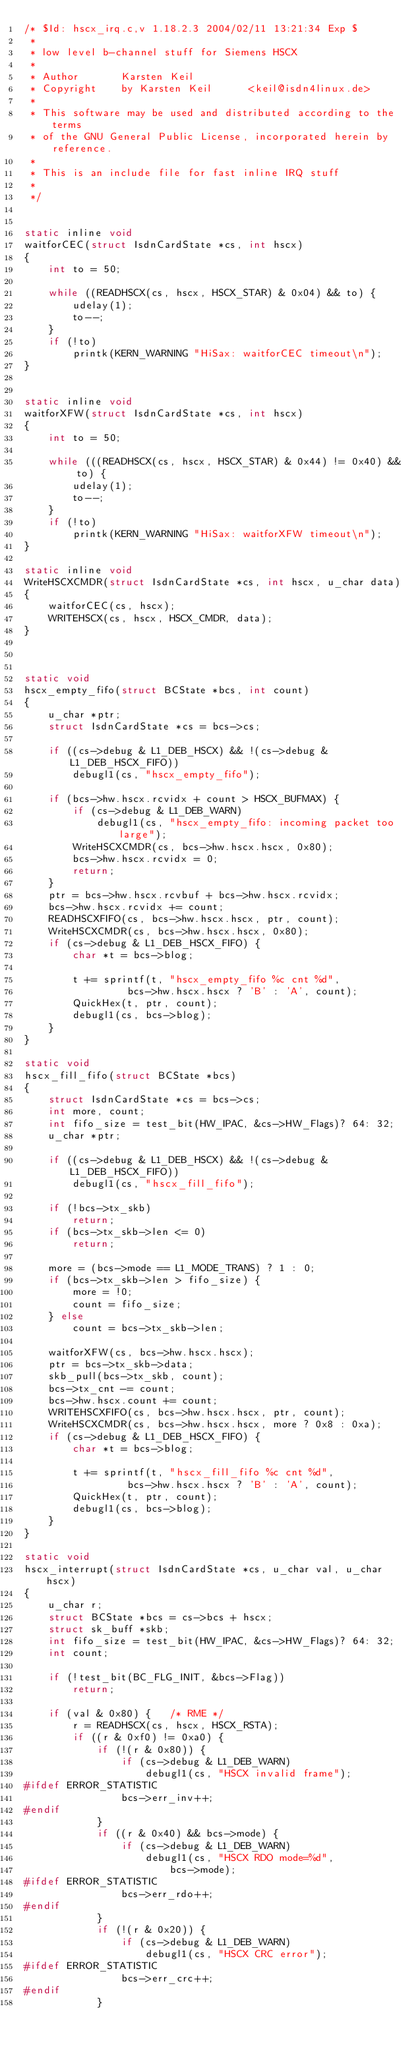Convert code to text. <code><loc_0><loc_0><loc_500><loc_500><_C_>/* $Id: hscx_irq.c,v 1.18.2.3 2004/02/11 13:21:34 Exp $
 *
 * low level b-channel stuff for Siemens HSCX
 *
 * Author       Karsten Keil
 * Copyright    by Karsten Keil      <keil@isdn4linux.de>
 * 
 * This software may be used and distributed according to the terms
 * of the GNU General Public License, incorporated herein by reference.
 *
 * This is an include file for fast inline IRQ stuff
 *
 */


static inline void
waitforCEC(struct IsdnCardState *cs, int hscx)
{
	int to = 50;

	while ((READHSCX(cs, hscx, HSCX_STAR) & 0x04) && to) {
		udelay(1);
		to--;
	}
	if (!to)
		printk(KERN_WARNING "HiSax: waitforCEC timeout\n");
}


static inline void
waitforXFW(struct IsdnCardState *cs, int hscx)
{
	int to = 50;

	while (((READHSCX(cs, hscx, HSCX_STAR) & 0x44) != 0x40) && to) {
		udelay(1);
		to--;
	}
	if (!to)
		printk(KERN_WARNING "HiSax: waitforXFW timeout\n");
}

static inline void
WriteHSCXCMDR(struct IsdnCardState *cs, int hscx, u_char data)
{
	waitforCEC(cs, hscx);
	WRITEHSCX(cs, hscx, HSCX_CMDR, data);
}



static void
hscx_empty_fifo(struct BCState *bcs, int count)
{
	u_char *ptr;
	struct IsdnCardState *cs = bcs->cs;

	if ((cs->debug & L1_DEB_HSCX) && !(cs->debug & L1_DEB_HSCX_FIFO))
		debugl1(cs, "hscx_empty_fifo");

	if (bcs->hw.hscx.rcvidx + count > HSCX_BUFMAX) {
		if (cs->debug & L1_DEB_WARN)
			debugl1(cs, "hscx_empty_fifo: incoming packet too large");
		WriteHSCXCMDR(cs, bcs->hw.hscx.hscx, 0x80);
		bcs->hw.hscx.rcvidx = 0;
		return;
	}
	ptr = bcs->hw.hscx.rcvbuf + bcs->hw.hscx.rcvidx;
	bcs->hw.hscx.rcvidx += count;
	READHSCXFIFO(cs, bcs->hw.hscx.hscx, ptr, count);
	WriteHSCXCMDR(cs, bcs->hw.hscx.hscx, 0x80);
	if (cs->debug & L1_DEB_HSCX_FIFO) {
		char *t = bcs->blog;

		t += sprintf(t, "hscx_empty_fifo %c cnt %d",
			     bcs->hw.hscx.hscx ? 'B' : 'A', count);
		QuickHex(t, ptr, count);
		debugl1(cs, bcs->blog);
	}
}

static void
hscx_fill_fifo(struct BCState *bcs)
{
	struct IsdnCardState *cs = bcs->cs;
	int more, count;
	int fifo_size = test_bit(HW_IPAC, &cs->HW_Flags)? 64: 32;
	u_char *ptr;

	if ((cs->debug & L1_DEB_HSCX) && !(cs->debug & L1_DEB_HSCX_FIFO))
		debugl1(cs, "hscx_fill_fifo");

	if (!bcs->tx_skb)
		return;
	if (bcs->tx_skb->len <= 0)
		return;

	more = (bcs->mode == L1_MODE_TRANS) ? 1 : 0;
	if (bcs->tx_skb->len > fifo_size) {
		more = !0;
		count = fifo_size;
	} else
		count = bcs->tx_skb->len;

	waitforXFW(cs, bcs->hw.hscx.hscx);
	ptr = bcs->tx_skb->data;
	skb_pull(bcs->tx_skb, count);
	bcs->tx_cnt -= count;
	bcs->hw.hscx.count += count;
	WRITEHSCXFIFO(cs, bcs->hw.hscx.hscx, ptr, count);
	WriteHSCXCMDR(cs, bcs->hw.hscx.hscx, more ? 0x8 : 0xa);
	if (cs->debug & L1_DEB_HSCX_FIFO) {
		char *t = bcs->blog;

		t += sprintf(t, "hscx_fill_fifo %c cnt %d",
			     bcs->hw.hscx.hscx ? 'B' : 'A', count);
		QuickHex(t, ptr, count);
		debugl1(cs, bcs->blog);
	}
}

static void
hscx_interrupt(struct IsdnCardState *cs, u_char val, u_char hscx)
{
	u_char r;
	struct BCState *bcs = cs->bcs + hscx;
	struct sk_buff *skb;
	int fifo_size = test_bit(HW_IPAC, &cs->HW_Flags)? 64: 32;
	int count;

	if (!test_bit(BC_FLG_INIT, &bcs->Flag))
		return;

	if (val & 0x80) {	/* RME */
		r = READHSCX(cs, hscx, HSCX_RSTA);
		if ((r & 0xf0) != 0xa0) {
			if (!(r & 0x80)) {
				if (cs->debug & L1_DEB_WARN)
					debugl1(cs, "HSCX invalid frame");
#ifdef ERROR_STATISTIC
				bcs->err_inv++;
#endif
			}
			if ((r & 0x40) && bcs->mode) {
				if (cs->debug & L1_DEB_WARN)
					debugl1(cs, "HSCX RDO mode=%d",
						bcs->mode);
#ifdef ERROR_STATISTIC
				bcs->err_rdo++;
#endif
			}
			if (!(r & 0x20)) {
				if (cs->debug & L1_DEB_WARN)
					debugl1(cs, "HSCX CRC error");
#ifdef ERROR_STATISTIC
				bcs->err_crc++;
#endif
			}</code> 